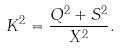Convert formula to latex. <formula><loc_0><loc_0><loc_500><loc_500>K ^ { 2 } = \frac { Q ^ { 2 } + S ^ { 2 } } { X ^ { 2 } } .</formula> 